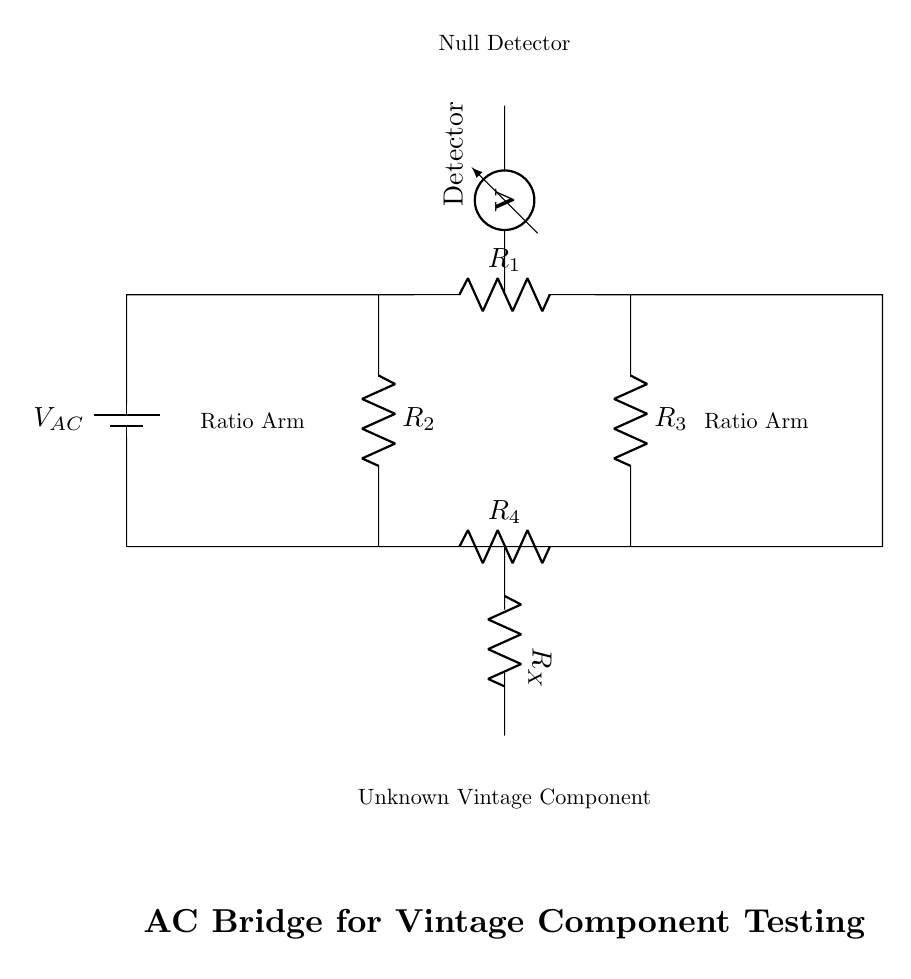What is the main function of the component labeled as "Detector"? The Detector is used to measure the voltage or current in the circuit, indicating whether a null condition is reached, which is critical for determining balance in an AC bridge.
Answer: Measure voltage What type of components are used in this circuit? The circuit primarily uses resistors and a voltmeter, along with an AC voltage source, which are standard components in testing circuits.
Answer: Resistors and voltmeter What does the term "Null Detector" refer to in this diagram? The Null Detector is used to find the point at which there is no voltage difference, representing balance in the bridge, crucial in accurately testing the unknown component.
Answer: Balance point Which resistors form the ratio arms of the bridge? Resistors R1 and R2 form one arm, while R3 and R4 are the other arm, providing the necessary balancing conditions for the circuit analysis.
Answer: R1, R2 (one arm); R3, R4 (other arm) What does the "Unknown Vintage Component" represent in the bridge circuit? This component, labeled as "R_X," is the vintage component being tested for quality and authenticity, its value being determined by the bridge's balance condition.
Answer: Vintage component What condition indicates that the AC bridge is balanced? The bridge is balanced when there is no current flowing through the Null Detector, indicating that the ratio of resistances is in equilibrium with the unknown component's impedance.
Answer: No current 